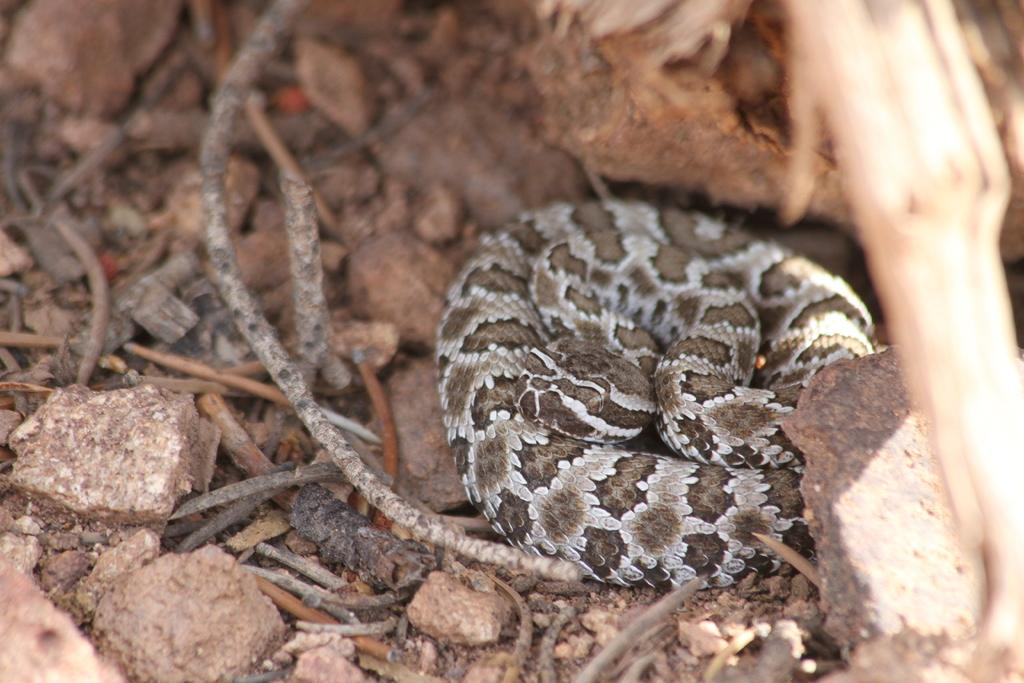What type of animal is in the image? There is a snake in the image. What can be seen on the ground in the image? There are stones on the ground in the image. What is the name of the thing on the snake's head in the image? There is no thing on the snake's head in the image, as the snake does not have a head visible in the image. 